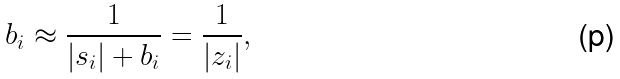<formula> <loc_0><loc_0><loc_500><loc_500>b _ { i } \approx \frac { 1 } { | s _ { i } | + b _ { i } } = \frac { 1 } { | z _ { i } | } ,</formula> 